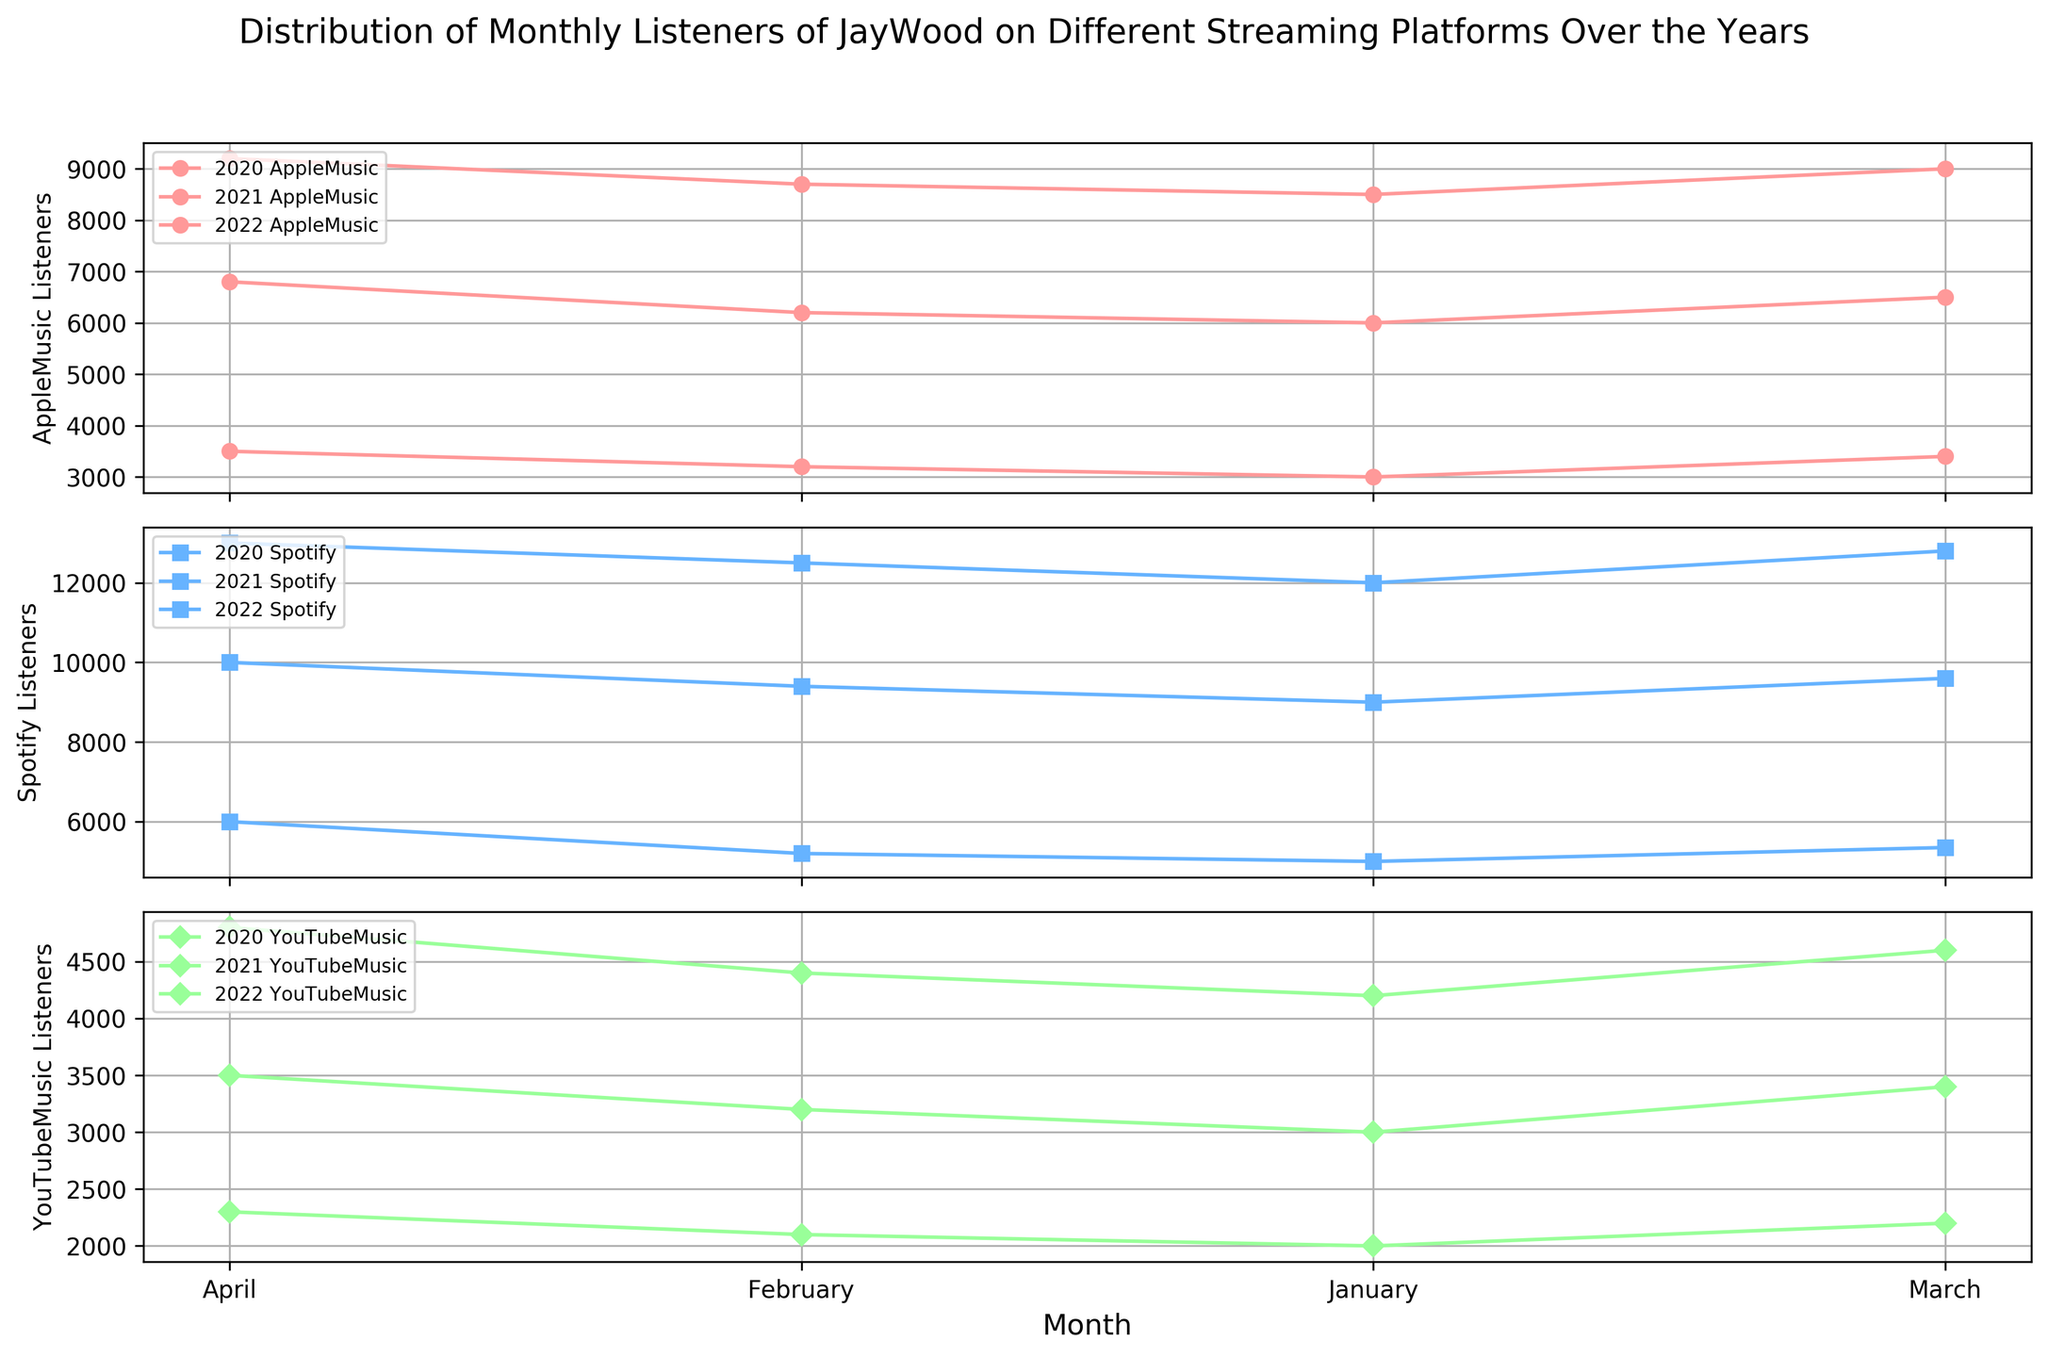Which platform had the highest number of monthly listeners in April 2022? Look at the bars for April 2022 across all platforms (Spotify, Apple Music, YouTube Music), and compare their heights. Spotify had the tallest bar.
Answer: Spotify How did the number of monthly listeners for YouTube Music in April 2021 compare to April 2020? Locate the bars for YouTube Music in April 2021 and April 2020, respectively, and compare their heights. The bar for April 2021 is taller.
Answer: Higher in April 2021 What is the total number of monthly listeners on Spotify and Apple Music in March 2022? Find the bars representing March 2022 for Spotify and Apple Music, then add the number of listeners for both platforms (12800 + 9000).
Answer: 21800 Did any platform see a decrease in monthly listeners from February to March 2021? Check the bars for each platform between February 2021 and March 2021 and see if the height of the bar decreases. None of the platforms showed a decrease in listeners during these months.
Answer: No Which platform had the steepest growth in monthly listeners from 2020 to 2021? Compare the slopes of the bars from 2020 to 2021 for each platform. Spotify's increase from around 5000 to about 9200 listeners is the steepest.
Answer: Spotify What is the average number of monthly listeners for Apple Music in the first quarter of 2022? Add the monthly listeners for Apple Music from January to March 2022 (8500 + 8700 + 9000) and divide by 3.
Answer: 8733.33 Which month in 2021 had the least number of listeners for YouTube Music? Compare the bars for YouTube Music across the months in 2021 and find the month with the shortest bar. January 2021 had the shortest bar.
Answer: January By how much did the monthly listeners for Spotify increase from January to April 2020? Subtract the January 2020 listeners from the April 2020 listeners of Spotify (6000 - 5000).
Answer: 1000 In which year did Apple Music see the greatest number of new monthly listeners in the month of January? Compare the bars for January across all the years for Apple Music to check which one is the highest. 2022 had the highest bar.
Answer: 2022 Is the number of monthly listeners for YouTube Music in February 2022 higher or lower than in February 2021? Compare the bars for YouTube Music in February 2022 and February 2021. The bar for February 2022 is higher.
Answer: Higher 